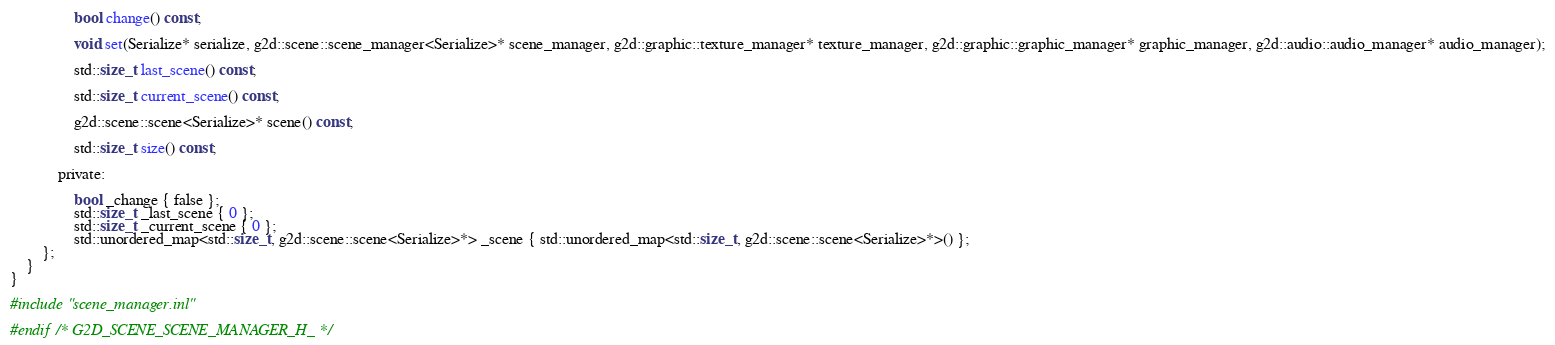<code> <loc_0><loc_0><loc_500><loc_500><_C_>				bool change() const;

				void set(Serialize* serialize, g2d::scene::scene_manager<Serialize>* scene_manager, g2d::graphic::texture_manager* texture_manager, g2d::graphic::graphic_manager* graphic_manager, g2d::audio::audio_manager* audio_manager);

				std::size_t last_scene() const;

				std::size_t current_scene() const;

				g2d::scene::scene<Serialize>* scene() const;

				std::size_t size() const;

			private:

				bool _change { false };
				std::size_t _last_scene { 0 };
				std::size_t _current_scene { 0 };
				std::unordered_map<std::size_t, g2d::scene::scene<Serialize>*> _scene { std::unordered_map<std::size_t, g2d::scene::scene<Serialize>*>() };
		};
	}
}

#include "scene_manager.inl"

#endif /* G2D_SCENE_SCENE_MANAGER_H_ */
</code> 